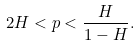Convert formula to latex. <formula><loc_0><loc_0><loc_500><loc_500>2 H < p < \frac { H } { 1 - H } .</formula> 